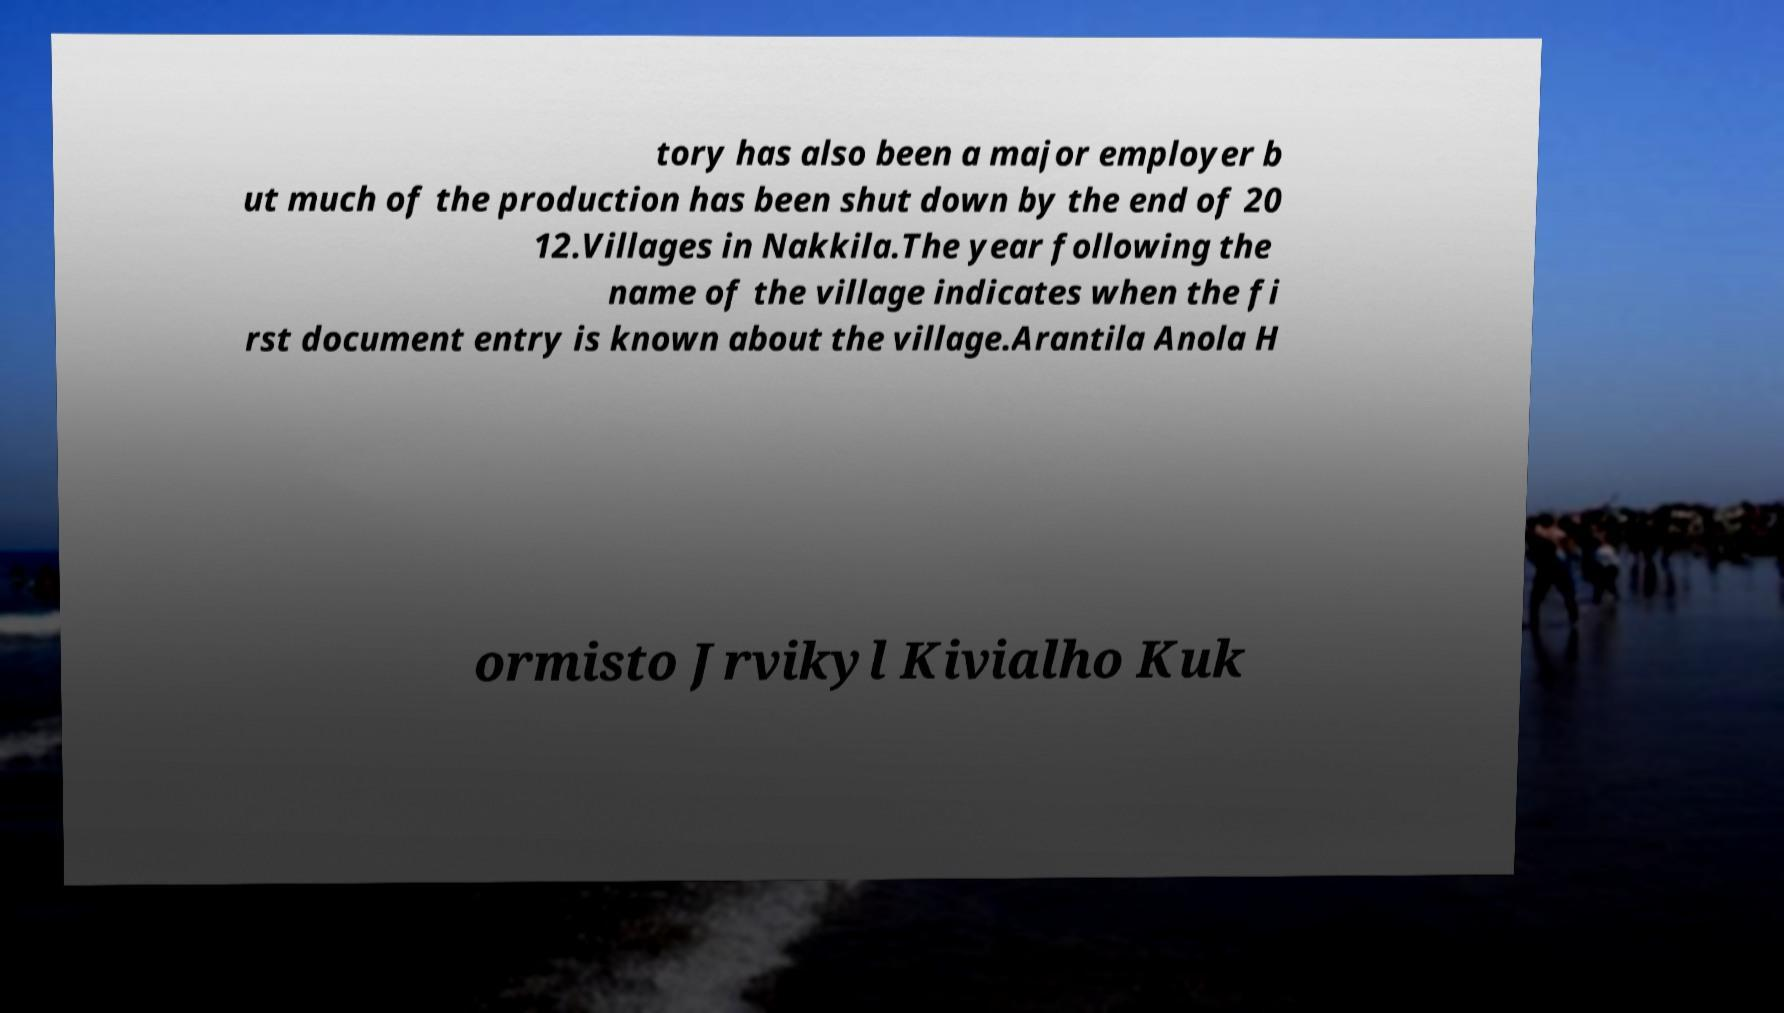Please read and relay the text visible in this image. What does it say? tory has also been a major employer b ut much of the production has been shut down by the end of 20 12.Villages in Nakkila.The year following the name of the village indicates when the fi rst document entry is known about the village.Arantila Anola H ormisto Jrvikyl Kivialho Kuk 